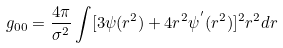Convert formula to latex. <formula><loc_0><loc_0><loc_500><loc_500>g _ { 0 0 } = \frac { 4 \pi } { \sigma ^ { 2 } } \int [ 3 \psi ( r ^ { 2 } ) + 4 r ^ { 2 } \psi ^ { ^ { \prime } } ( r ^ { 2 } ) ] ^ { 2 } r ^ { 2 } d r</formula> 